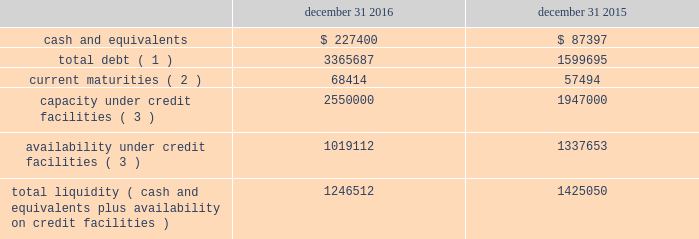Liquidity and capital resources the table summarizes liquidity data as of the dates indicated ( in thousands ) : december 31 , december 31 .
Total debt ( 1 ) 3365687 1599695 current maturities ( 2 ) 68414 57494 capacity under credit facilities ( 3 ) 2550000 1947000 availability under credit facilities ( 3 ) 1019112 1337653 total liquidity ( cash and equivalents plus availability on credit facilities ) 1246512 1425050 ( 1 ) debt amounts reflect the gross values to be repaid ( excluding debt issuance costs of $ 23.9 million and $ 15.0 million as of december 31 , 2016 and 2015 , respectively ) .
( 2 ) debt amounts reflect the gross values to be repaid ( excluding debt issuance costs of $ 2.3 million and $ 1.5 million as of december 31 , 2016 and 2015 , respectively ) .
( 3 ) includes our revolving credit facilities , our receivables securitization facility , and letters of credit .
We assess our liquidity in terms of our ability to fund our operations and provide for expansion through both internal development and acquisitions .
Our primary sources of liquidity are cash flows from operations and our credit facilities .
We utilize our cash flows from operations to fund working capital and capital expenditures , with the excess amounts going towards funding acquisitions or paying down outstanding debt .
As we have pursued acquisitions as part of our growth strategy , our cash flows from operations have not always been sufficient to cover our investing activities .
To fund our acquisitions , we have accessed various forms of debt financing , including revolving credit facilities , senior notes , and a receivables securitization facility .
As of december 31 , 2016 , we had debt outstanding and additional available sources of financing , as follows : 2022 senior secured credit facilities maturing in january 2021 , composed of term loans totaling $ 750 million ( $ 732.7 million outstanding at december 31 , 2016 ) and $ 2.45 billion in revolving credit ( $ 1.36 billion outstanding at december 31 , 2016 ) , bearing interest at variable rates ( although a portion of this debt is hedged through interest rate swap contracts ) reduced by $ 72.7 million of amounts outstanding under letters of credit 2022 senior notes totaling $ 600 million , maturing in may 2023 and bearing interest at a 4.75% ( 4.75 % ) fixed rate 2022 euro notes totaling $ 526 million ( 20ac500 million ) , maturing in april 2024 and bearing interest at a 3.875% ( 3.875 % ) fixed rate 2022 receivables securitization facility with availability up to $ 100 million ( $ 100 million outstanding as of december 31 , 2016 ) , maturing in november 2019 and bearing interest at variable commercial paper from time to time , we may undertake financing transactions to increase our available liquidity , such as our january 2016 amendment to our senior secured credit facilities , the issuance of 20ac500 million of euro notes in april 2016 , and the november 2016 amendment to our receivables securitization facility .
The rhiag acquisition was the catalyst for the april issuance of 20ac500 million of euro notes .
Given that rhiag is a long term asset , we considered alternative financing options and decided to fund a portion of this acquisition through the issuance of long term notes .
Additionally , the interest rates on rhiag's acquired debt ranged between 6.45% ( 6.45 % ) and 7.25% ( 7.25 % ) .
With the issuance of the 20ac500 million of senior notes at a rate of 3.875% ( 3.875 % ) , we were able to replace rhiag's borrowings with long term financing at favorable rates .
This refinancing also provides financial flexibility to execute our long-term growth strategy by freeing up availability under our revolver .
If we see an attractive acquisition opportunity , we have the ability to use our revolver to move quickly and have certainty of funding .
As of december 31 , 2016 , we had approximately $ 1.02 billion available under our credit facilities .
Combined with approximately $ 227.4 million of cash and equivalents at december 31 , 2016 , we had approximately $ 1.25 billion in available liquidity , a decrease of $ 178.5 million from our available liquidity as of december 31 , 2015 .
We expect to use the proceeds from the sale of pgw's glass manufacturing business to pay down borrowings under our revolving credit facilities , which would increase our available liquidity by approximately $ 310 million when the transaction closes. .
Based on the review of the liquidity and capital resources what was the ratio of the cash and equivalents in 2016 compared to 2015? 
Computations: (227400 / 87397)
Answer: 2.60192. 